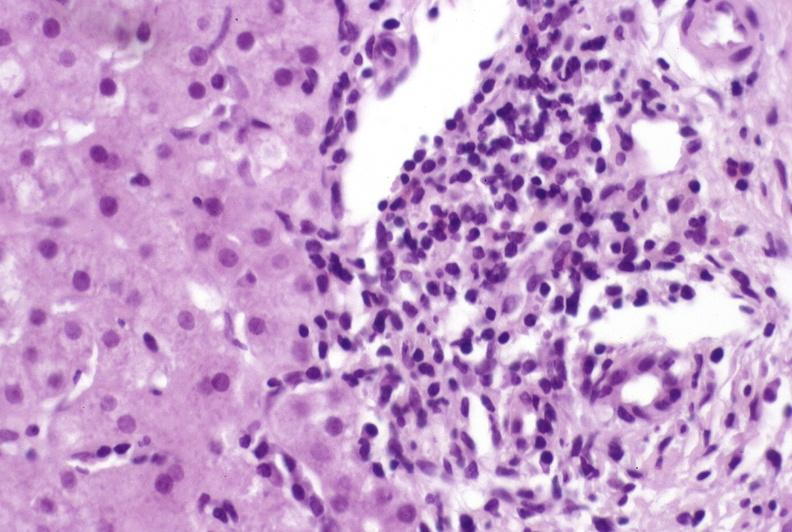s atrophy present?
Answer the question using a single word or phrase. No 